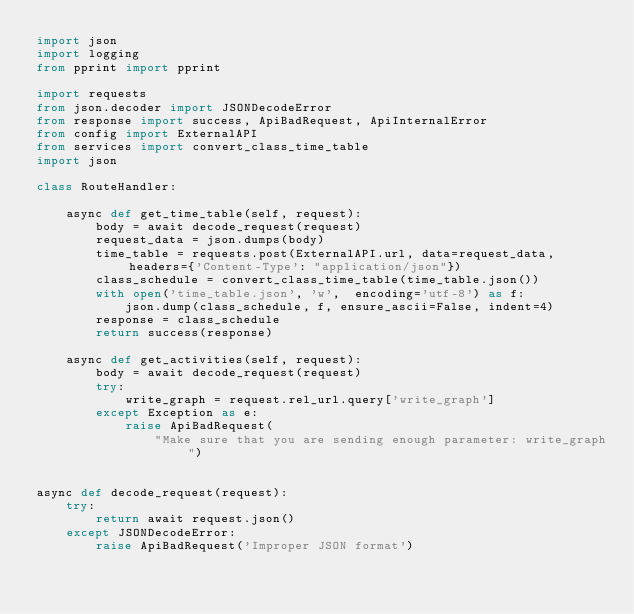Convert code to text. <code><loc_0><loc_0><loc_500><loc_500><_Python_>import json
import logging
from pprint import pprint

import requests
from json.decoder import JSONDecodeError
from response import success, ApiBadRequest, ApiInternalError
from config import ExternalAPI
from services import convert_class_time_table
import json

class RouteHandler:

    async def get_time_table(self, request):
        body = await decode_request(request)
        request_data = json.dumps(body)
        time_table = requests.post(ExternalAPI.url, data=request_data, headers={'Content-Type': "application/json"})
        class_schedule = convert_class_time_table(time_table.json())
        with open('time_table.json', 'w',  encoding='utf-8') as f:
            json.dump(class_schedule, f, ensure_ascii=False, indent=4)
        response = class_schedule
        return success(response)

    async def get_activities(self, request):
        body = await decode_request(request)
        try:
            write_graph = request.rel_url.query['write_graph']
        except Exception as e:
            raise ApiBadRequest(
                "Make sure that you are sending enough parameter: write_graph")


async def decode_request(request):
    try:
        return await request.json()
    except JSONDecodeError:
        raise ApiBadRequest('Improper JSON format')
</code> 